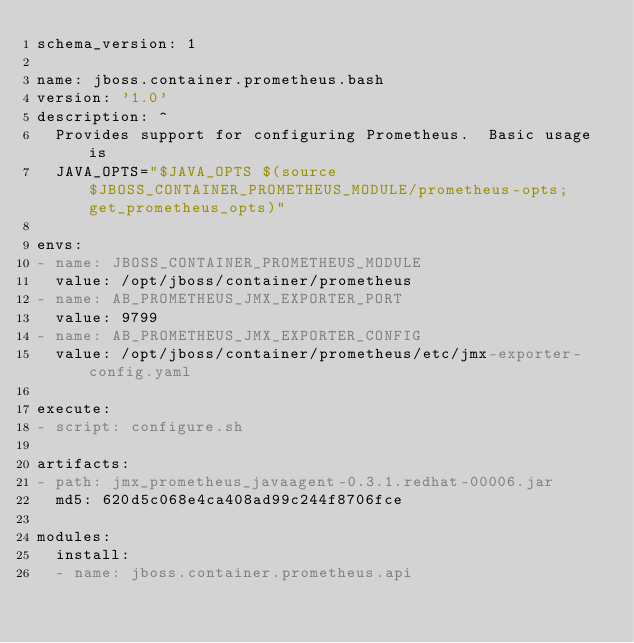Convert code to text. <code><loc_0><loc_0><loc_500><loc_500><_YAML_>schema_version: 1

name: jboss.container.prometheus.bash
version: '1.0'
description: ^
  Provides support for configuring Prometheus.  Basic usage is
  JAVA_OPTS="$JAVA_OPTS $(source $JBOSS_CONTAINER_PROMETHEUS_MODULE/prometheus-opts; get_prometheus_opts)"

envs:
- name: JBOSS_CONTAINER_PROMETHEUS_MODULE
  value: /opt/jboss/container/prometheus
- name: AB_PROMETHEUS_JMX_EXPORTER_PORT
  value: 9799
- name: AB_PROMETHEUS_JMX_EXPORTER_CONFIG
  value: /opt/jboss/container/prometheus/etc/jmx-exporter-config.yaml

execute:
- script: configure.sh

artifacts:
- path: jmx_prometheus_javaagent-0.3.1.redhat-00006.jar
  md5: 620d5c068e4ca408ad99c244f8706fce

modules:
  install:
  - name: jboss.container.prometheus.api
</code> 